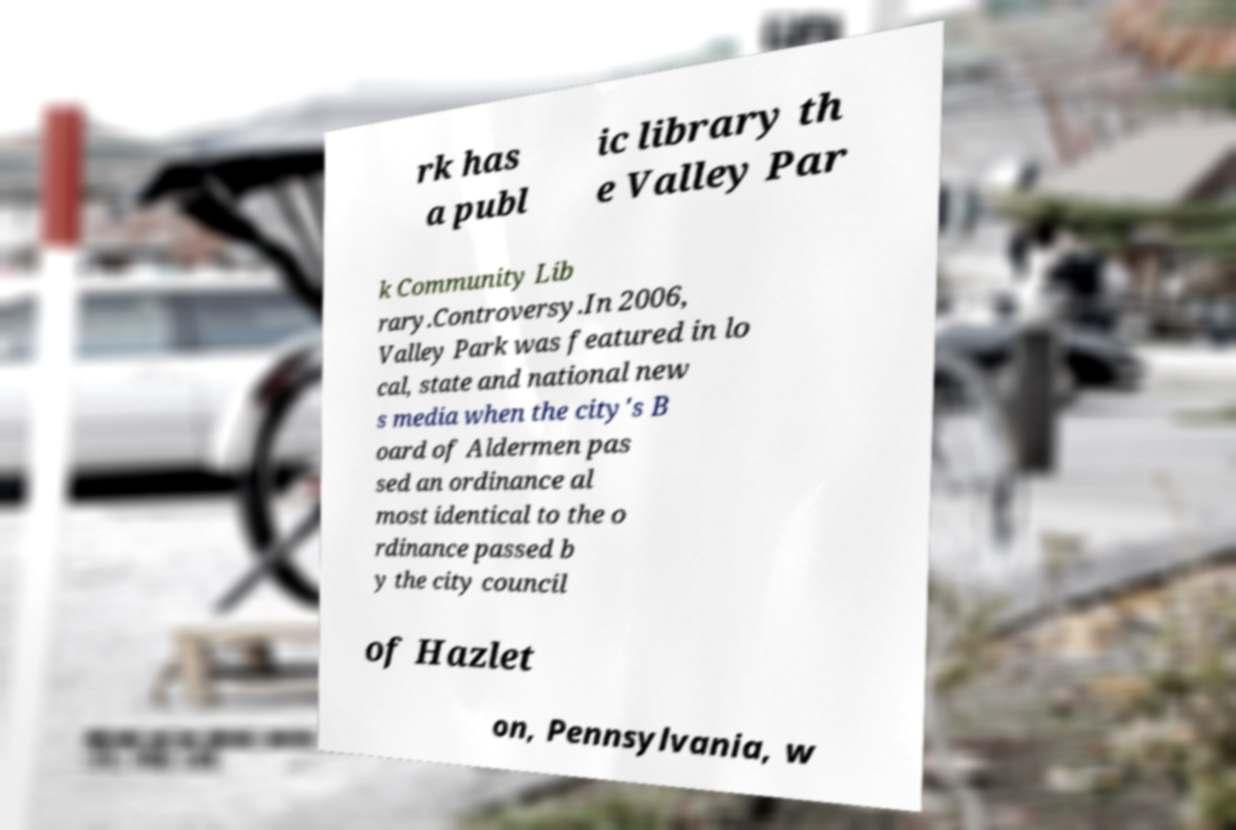Could you assist in decoding the text presented in this image and type it out clearly? rk has a publ ic library th e Valley Par k Community Lib rary.Controversy.In 2006, Valley Park was featured in lo cal, state and national new s media when the city's B oard of Aldermen pas sed an ordinance al most identical to the o rdinance passed b y the city council of Hazlet on, Pennsylvania, w 